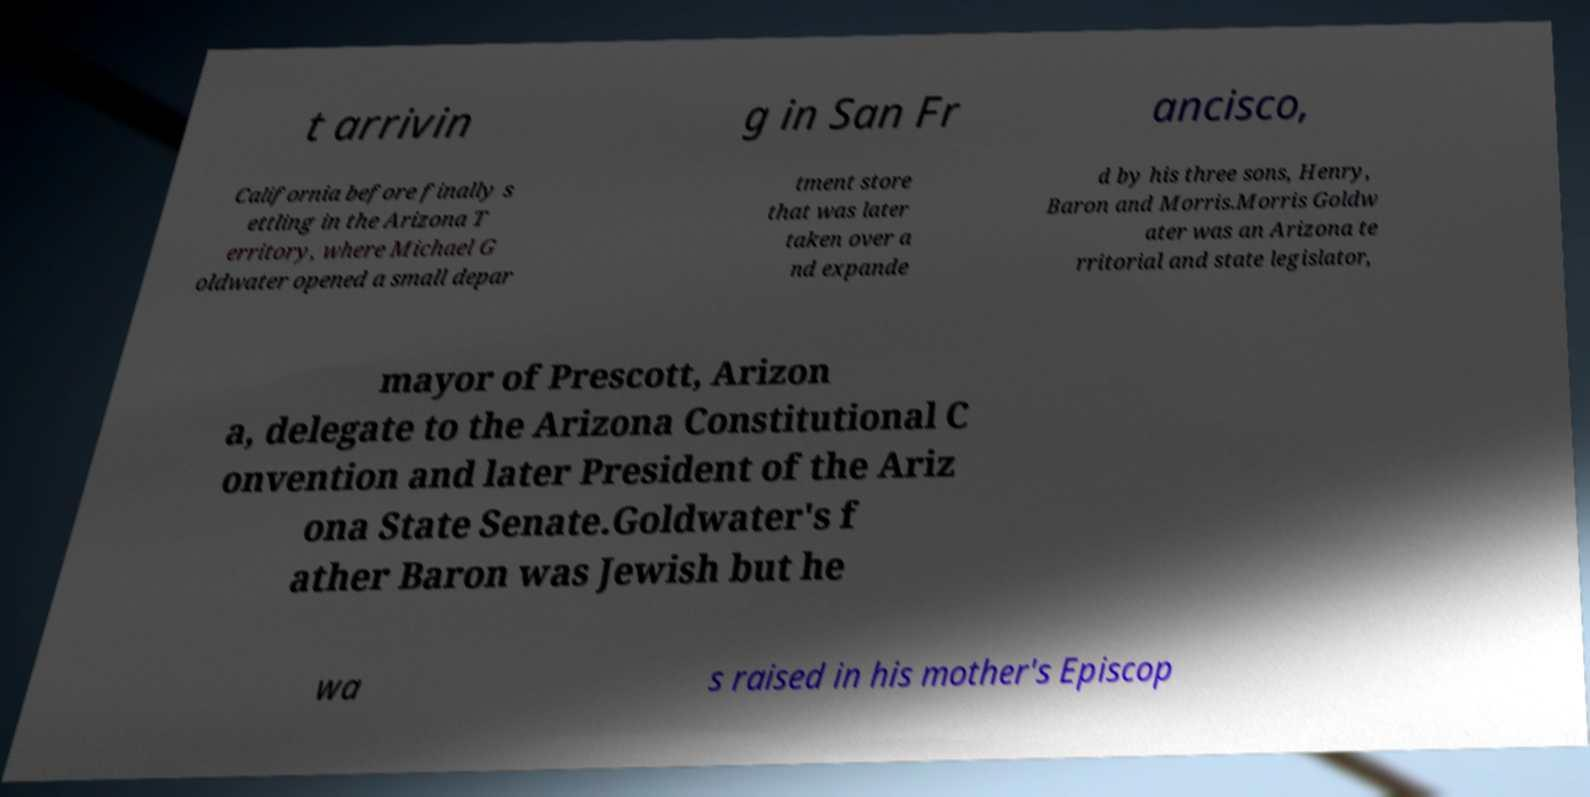Please identify and transcribe the text found in this image. t arrivin g in San Fr ancisco, California before finally s ettling in the Arizona T erritory, where Michael G oldwater opened a small depar tment store that was later taken over a nd expande d by his three sons, Henry, Baron and Morris.Morris Goldw ater was an Arizona te rritorial and state legislator, mayor of Prescott, Arizon a, delegate to the Arizona Constitutional C onvention and later President of the Ariz ona State Senate.Goldwater's f ather Baron was Jewish but he wa s raised in his mother's Episcop 